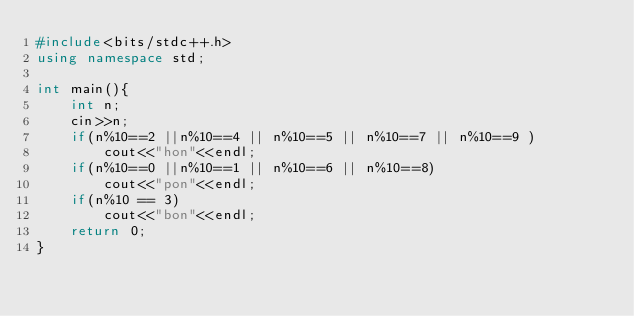<code> <loc_0><loc_0><loc_500><loc_500><_C++_>#include<bits/stdc++.h>
using namespace std;

int main(){
    int n;
    cin>>n;
    if(n%10==2 ||n%10==4 || n%10==5 || n%10==7 || n%10==9 )
        cout<<"hon"<<endl;
    if(n%10==0 ||n%10==1 || n%10==6 || n%10==8)
        cout<<"pon"<<endl;
    if(n%10 == 3)
        cout<<"bon"<<endl;
    return 0;
}</code> 